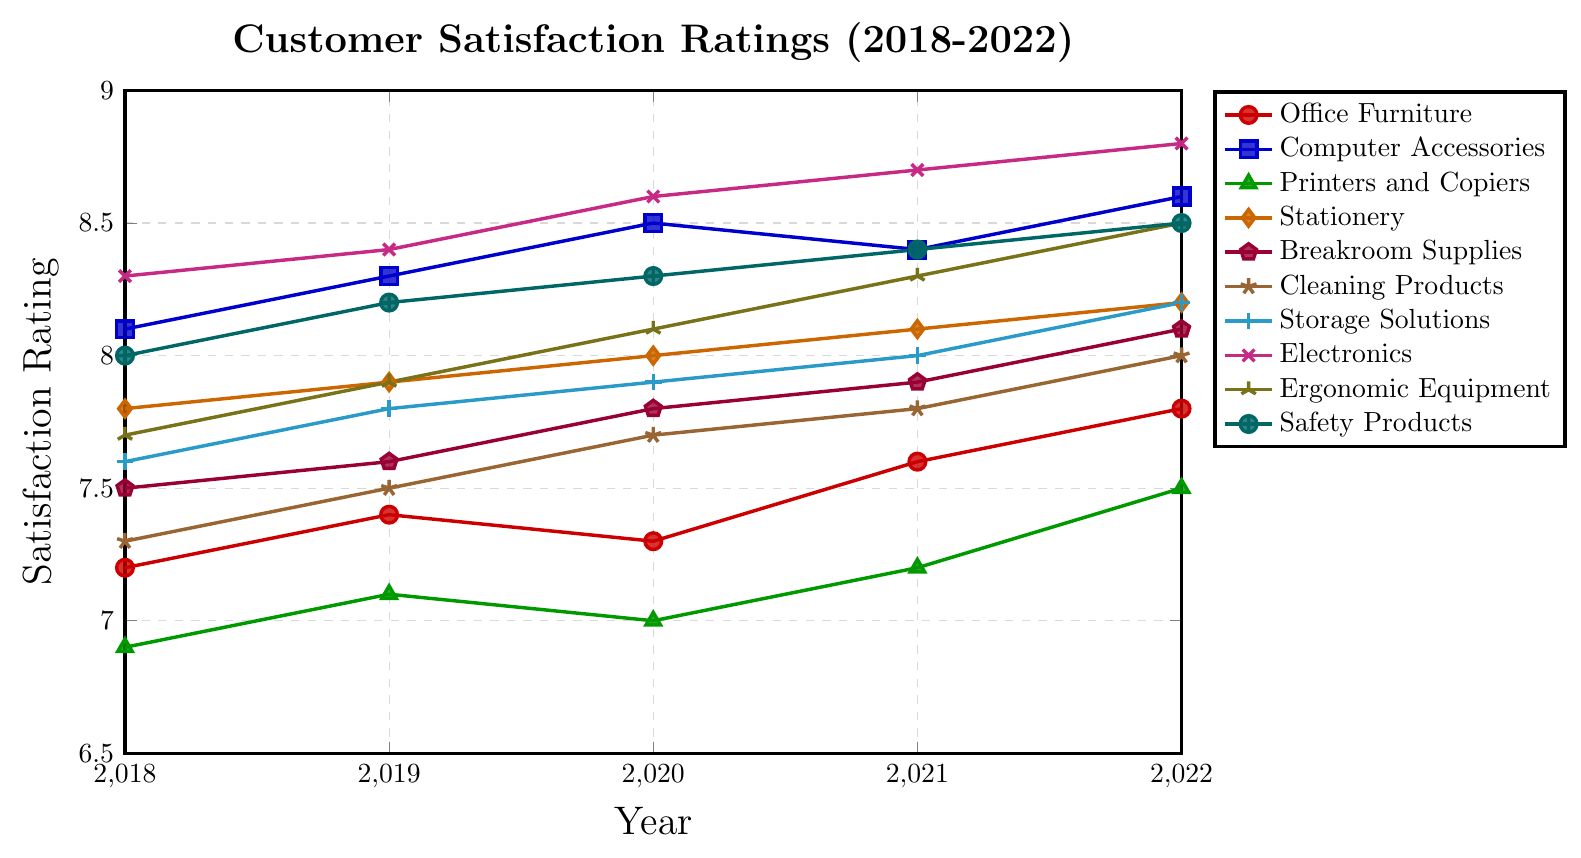Which product line had the highest customer satisfaction rating in 2022? In 2022, the highest rating is represented by the point at the top of the y-axis. The product line corresponding to this point is Electronics with a rating of 8.8.
Answer: Electronics Which year had the lowest customer satisfaction rating for Printers and Copiers, and what was the rating? Looking at the green line with triangle markers, the lowest point is in 2018. The rating for Printers and Copiers in that year was 6.9.
Answer: 2018, 6.9 How did the customer satisfaction rating for Office Furniture change from 2018 to 2022? Starting in 2018 with a rating of 7.2 and ending in 2022 with a rating of 7.8, Office Furniture saw an overall increase. The difference is 7.8 - 7.2 = 0.6.
Answer: Increased by 0.6 Which product lines had an increase in customer satisfaction rating from 2019 to 2021? By examining each line from 2019 to 2021, all lines except Computer Accessories (blue) show an increase.
Answer: All except Computer Accessories What is the average customer satisfaction rating for Cleaning Products across the years shown? Summing the ratings for Cleaning Products (7.3, 7.5, 7.7, 7.8, 8.0) gives 38.3. Dividing by 5 years, the average rating is 38.3 / 5 = 7.66.
Answer: 7.66 Compare the customer satisfaction trends for Electronics and Safety Products from 2018 to 2022. Electronics (magenta) shows a constant increase from 8.3 to 8.8. Safety Products (teal) also show a steady increase from 8.0 to 8.5 but at a slightly lower overall rating.
Answer: Both increased, Electronics increased more Which year had the closest average customer satisfaction rating for Storage Solutions and Office Furniture? Calculating the average for each year: (7.6+7.2)/2, (7.8+7.4)/2, (7.9+7.3)/2, (8.0+7.6)/2, (8.2+7.8)/2. The closest averages: 2018 (7.4), 2019 (7.6), 2020 (7.6), 2021 (7.8), 2022 (8.0). The differences are closest in 2021.
Answer: 2021 In which year did Breakroom Supplies see the largest increase in customer satisfaction rating compared to the previous year? Breakroom Supplies (purple) had ratings of 7.5, 7.6, 7.8, 7.9, 8.1. Calculating differences: 0.1, 0.2, 0.1, 0.2. Largest increase was from 2020 to 2021 (0.2).
Answer: 2020 to 2021 